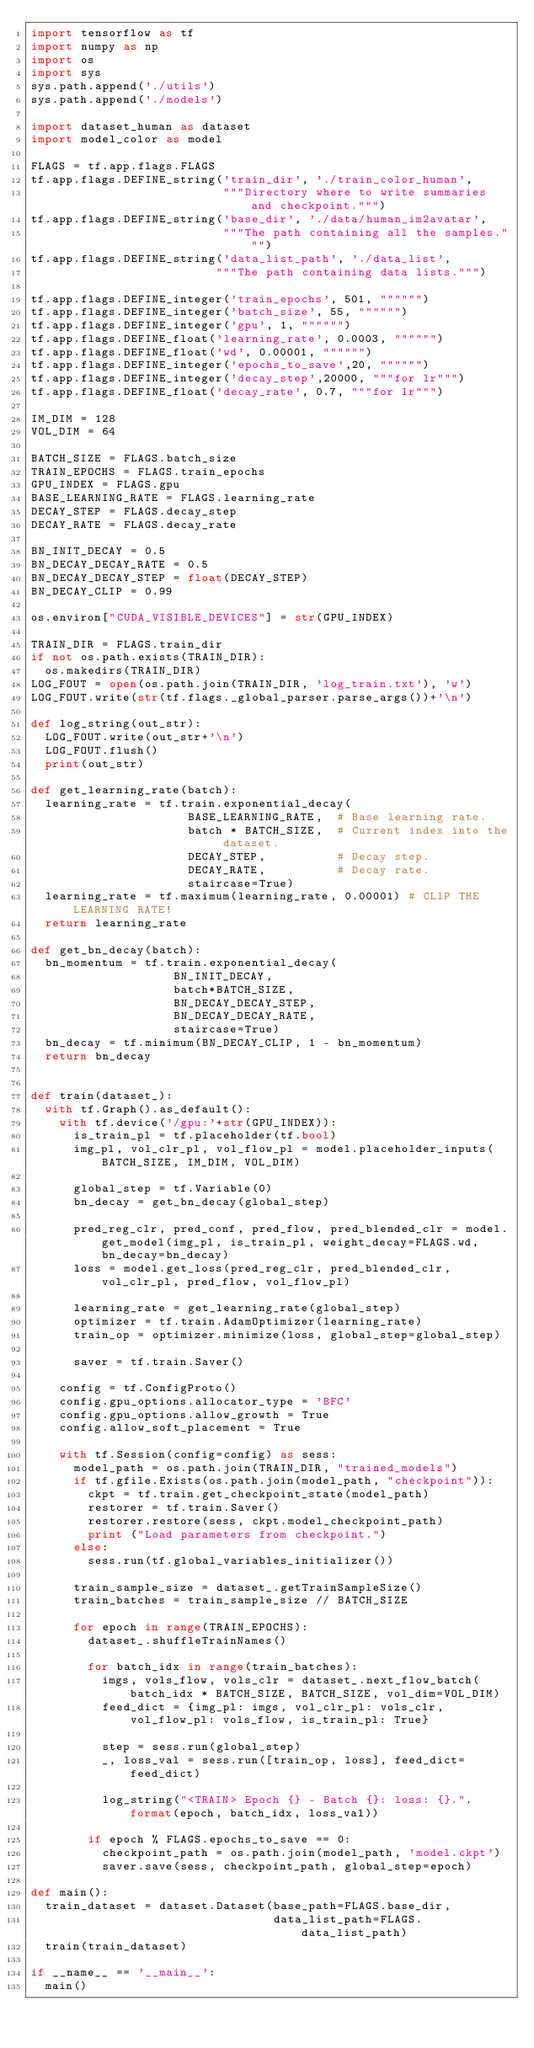<code> <loc_0><loc_0><loc_500><loc_500><_Python_>import tensorflow as tf
import numpy as np
import os
import sys
sys.path.append('./utils')
sys.path.append('./models')

import dataset_human as dataset
import model_color as model

FLAGS = tf.app.flags.FLAGS
tf.app.flags.DEFINE_string('train_dir', './train_color_human',
                           """Directory where to write summaries and checkpoint.""")
tf.app.flags.DEFINE_string('base_dir', './data/human_im2avatar', 
                           """The path containing all the samples.""")
tf.app.flags.DEFINE_string('data_list_path', './data_list', 
                          """The path containing data lists.""")

tf.app.flags.DEFINE_integer('train_epochs', 501, """""")
tf.app.flags.DEFINE_integer('batch_size', 55, """""")
tf.app.flags.DEFINE_integer('gpu', 1, """""")
tf.app.flags.DEFINE_float('learning_rate', 0.0003, """""")
tf.app.flags.DEFINE_float('wd', 0.00001, """""")
tf.app.flags.DEFINE_integer('epochs_to_save',20, """""")
tf.app.flags.DEFINE_integer('decay_step',20000, """for lr""")
tf.app.flags.DEFINE_float('decay_rate', 0.7, """for lr""")

IM_DIM = 128 
VOL_DIM = 64 

BATCH_SIZE = FLAGS.batch_size
TRAIN_EPOCHS = FLAGS.train_epochs
GPU_INDEX = FLAGS.gpu
BASE_LEARNING_RATE = FLAGS.learning_rate
DECAY_STEP = FLAGS.decay_step
DECAY_RATE = FLAGS.decay_rate

BN_INIT_DECAY = 0.5
BN_DECAY_DECAY_RATE = 0.5
BN_DECAY_DECAY_STEP = float(DECAY_STEP)
BN_DECAY_CLIP = 0.99

os.environ["CUDA_VISIBLE_DEVICES"] = str(GPU_INDEX)

TRAIN_DIR = FLAGS.train_dir
if not os.path.exists(TRAIN_DIR): 
  os.makedirs(TRAIN_DIR)
LOG_FOUT = open(os.path.join(TRAIN_DIR, 'log_train.txt'), 'w')
LOG_FOUT.write(str(tf.flags._global_parser.parse_args())+'\n')

def log_string(out_str):
  LOG_FOUT.write(out_str+'\n')
  LOG_FOUT.flush()
  print(out_str)

def get_learning_rate(batch):
  learning_rate = tf.train.exponential_decay(
                      BASE_LEARNING_RATE,  # Base learning rate.
                      batch * BATCH_SIZE,  # Current index into the dataset.
                      DECAY_STEP,          # Decay step.
                      DECAY_RATE,          # Decay rate.
                      staircase=True)
  learning_rate = tf.maximum(learning_rate, 0.00001) # CLIP THE LEARNING RATE!
  return learning_rate 

def get_bn_decay(batch):
  bn_momentum = tf.train.exponential_decay(
                    BN_INIT_DECAY,
                    batch*BATCH_SIZE,
                    BN_DECAY_DECAY_STEP,
                    BN_DECAY_DECAY_RATE,
                    staircase=True)
  bn_decay = tf.minimum(BN_DECAY_CLIP, 1 - bn_momentum)
  return bn_decay 


def train(dataset_):
  with tf.Graph().as_default():
    with tf.device('/gpu:'+str(GPU_INDEX)):
      is_train_pl = tf.placeholder(tf.bool)
      img_pl, vol_clr_pl, vol_flow_pl = model.placeholder_inputs(BATCH_SIZE, IM_DIM, VOL_DIM)

      global_step = tf.Variable(0)
      bn_decay = get_bn_decay(global_step)
    
      pred_reg_clr, pred_conf, pred_flow, pred_blended_clr = model.get_model(img_pl, is_train_pl, weight_decay=FLAGS.wd, bn_decay=bn_decay)
      loss = model.get_loss(pred_reg_clr, pred_blended_clr, vol_clr_pl, pred_flow, vol_flow_pl)
     
      learning_rate = get_learning_rate(global_step)
      optimizer = tf.train.AdamOptimizer(learning_rate)
      train_op = optimizer.minimize(loss, global_step=global_step)

      saver = tf.train.Saver()

    config = tf.ConfigProto()
    config.gpu_options.allocator_type = 'BFC'
    config.gpu_options.allow_growth = True
    config.allow_soft_placement = True

    with tf.Session(config=config) as sess:
      model_path = os.path.join(TRAIN_DIR, "trained_models")
      if tf.gfile.Exists(os.path.join(model_path, "checkpoint")):
        ckpt = tf.train.get_checkpoint_state(model_path)
        restorer = tf.train.Saver()
        restorer.restore(sess, ckpt.model_checkpoint_path)
        print ("Load parameters from checkpoint.")
      else:
        sess.run(tf.global_variables_initializer())

      train_sample_size = dataset_.getTrainSampleSize()
      train_batches = train_sample_size // BATCH_SIZE

      for epoch in range(TRAIN_EPOCHS):
        dataset_.shuffleTrainNames()

        for batch_idx in range(train_batches):
          imgs, vols_flow, vols_clr = dataset_.next_flow_batch(batch_idx * BATCH_SIZE, BATCH_SIZE, vol_dim=VOL_DIM)          
          feed_dict = {img_pl: imgs, vol_clr_pl: vols_clr, vol_flow_pl: vols_flow, is_train_pl: True}

          step = sess.run(global_step)
          _, loss_val = sess.run([train_op, loss], feed_dict=feed_dict)

          log_string("<TRAIN> Epoch {} - Batch {}: loss: {}.".format(epoch, batch_idx, loss_val))

        if epoch % FLAGS.epochs_to_save == 0:
          checkpoint_path = os.path.join(model_path, 'model.ckpt')
          saver.save(sess, checkpoint_path, global_step=epoch)

def main():
  train_dataset = dataset.Dataset(base_path=FLAGS.base_dir, 
                                  data_list_path=FLAGS.data_list_path)
  train(train_dataset)

if __name__ == '__main__':
  main()




</code> 